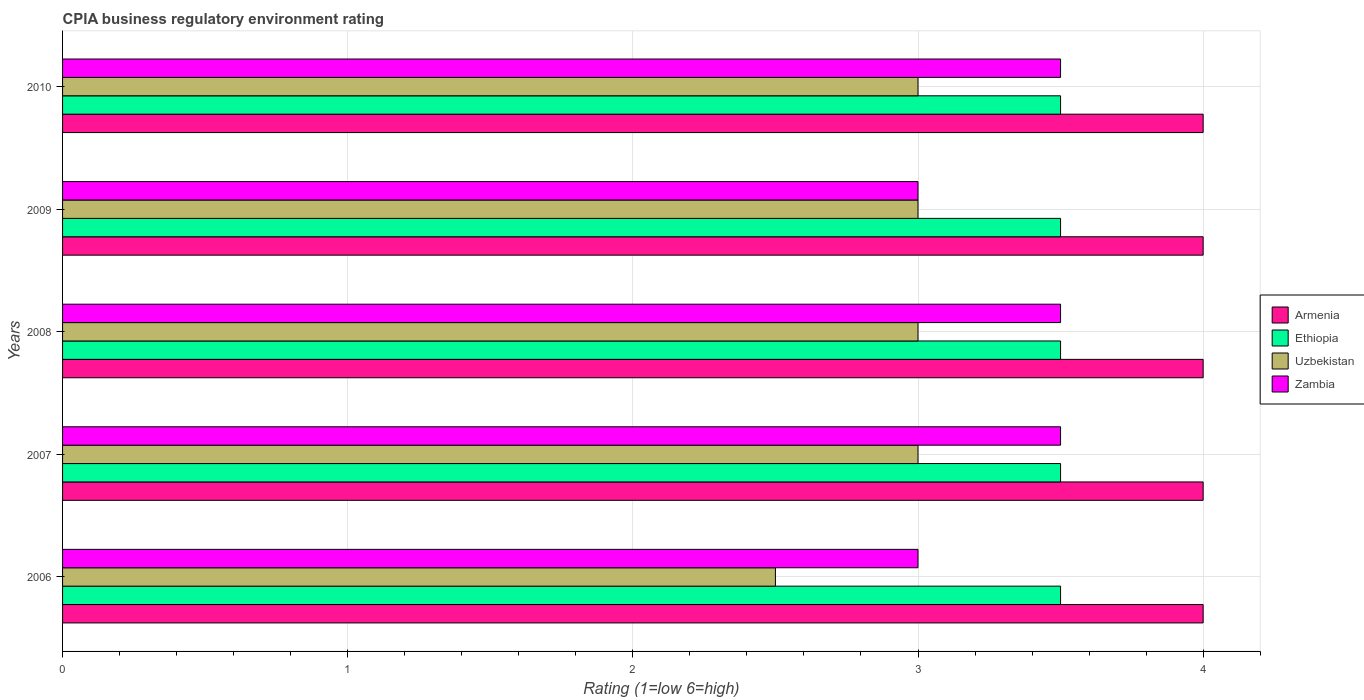How many groups of bars are there?
Offer a terse response. 5. Are the number of bars per tick equal to the number of legend labels?
Offer a very short reply. Yes. Are the number of bars on each tick of the Y-axis equal?
Your answer should be compact. Yes. How many bars are there on the 2nd tick from the top?
Offer a terse response. 4. How many bars are there on the 5th tick from the bottom?
Your answer should be very brief. 4. What is the label of the 3rd group of bars from the top?
Your answer should be compact. 2008. In how many cases, is the number of bars for a given year not equal to the number of legend labels?
Provide a succinct answer. 0. What is the CPIA rating in Zambia in 2007?
Your answer should be very brief. 3.5. What is the total CPIA rating in Armenia in the graph?
Your answer should be compact. 20. What is the difference between the CPIA rating in Armenia in 2007 and that in 2009?
Your response must be concise. 0. What is the average CPIA rating in Ethiopia per year?
Your answer should be very brief. 3.5. In the year 2010, what is the difference between the CPIA rating in Zambia and CPIA rating in Ethiopia?
Your answer should be compact. 0. Is the difference between the CPIA rating in Zambia in 2008 and 2009 greater than the difference between the CPIA rating in Ethiopia in 2008 and 2009?
Give a very brief answer. Yes. In how many years, is the CPIA rating in Armenia greater than the average CPIA rating in Armenia taken over all years?
Make the answer very short. 0. Is the sum of the CPIA rating in Armenia in 2008 and 2009 greater than the maximum CPIA rating in Uzbekistan across all years?
Your response must be concise. Yes. What does the 3rd bar from the top in 2006 represents?
Your response must be concise. Ethiopia. What does the 2nd bar from the bottom in 2010 represents?
Make the answer very short. Ethiopia. Is it the case that in every year, the sum of the CPIA rating in Zambia and CPIA rating in Armenia is greater than the CPIA rating in Ethiopia?
Provide a short and direct response. Yes. How many bars are there?
Keep it short and to the point. 20. What is the difference between two consecutive major ticks on the X-axis?
Give a very brief answer. 1. Are the values on the major ticks of X-axis written in scientific E-notation?
Your response must be concise. No. Does the graph contain any zero values?
Provide a short and direct response. No. Does the graph contain grids?
Offer a very short reply. Yes. Where does the legend appear in the graph?
Offer a terse response. Center right. How many legend labels are there?
Provide a short and direct response. 4. How are the legend labels stacked?
Give a very brief answer. Vertical. What is the title of the graph?
Ensure brevity in your answer.  CPIA business regulatory environment rating. What is the Rating (1=low 6=high) of Armenia in 2006?
Provide a short and direct response. 4. What is the Rating (1=low 6=high) in Armenia in 2007?
Offer a terse response. 4. What is the Rating (1=low 6=high) in Armenia in 2008?
Ensure brevity in your answer.  4. What is the Rating (1=low 6=high) in Ethiopia in 2008?
Ensure brevity in your answer.  3.5. What is the Rating (1=low 6=high) of Ethiopia in 2009?
Your response must be concise. 3.5. What is the Rating (1=low 6=high) of Zambia in 2010?
Your answer should be very brief. 3.5. Across all years, what is the maximum Rating (1=low 6=high) in Armenia?
Give a very brief answer. 4. Across all years, what is the maximum Rating (1=low 6=high) in Uzbekistan?
Make the answer very short. 3. Across all years, what is the maximum Rating (1=low 6=high) in Zambia?
Keep it short and to the point. 3.5. Across all years, what is the minimum Rating (1=low 6=high) of Armenia?
Provide a succinct answer. 4. Across all years, what is the minimum Rating (1=low 6=high) in Uzbekistan?
Offer a terse response. 2.5. Across all years, what is the minimum Rating (1=low 6=high) of Zambia?
Offer a terse response. 3. What is the total Rating (1=low 6=high) of Ethiopia in the graph?
Keep it short and to the point. 17.5. What is the total Rating (1=low 6=high) of Uzbekistan in the graph?
Offer a terse response. 14.5. What is the total Rating (1=low 6=high) in Zambia in the graph?
Provide a short and direct response. 16.5. What is the difference between the Rating (1=low 6=high) of Armenia in 2006 and that in 2008?
Provide a short and direct response. 0. What is the difference between the Rating (1=low 6=high) in Ethiopia in 2006 and that in 2008?
Keep it short and to the point. 0. What is the difference between the Rating (1=low 6=high) in Uzbekistan in 2006 and that in 2008?
Your answer should be very brief. -0.5. What is the difference between the Rating (1=low 6=high) in Zambia in 2006 and that in 2008?
Give a very brief answer. -0.5. What is the difference between the Rating (1=low 6=high) of Ethiopia in 2006 and that in 2009?
Offer a very short reply. 0. What is the difference between the Rating (1=low 6=high) in Uzbekistan in 2006 and that in 2009?
Ensure brevity in your answer.  -0.5. What is the difference between the Rating (1=low 6=high) of Zambia in 2006 and that in 2009?
Your answer should be very brief. 0. What is the difference between the Rating (1=low 6=high) in Armenia in 2006 and that in 2010?
Your answer should be very brief. 0. What is the difference between the Rating (1=low 6=high) of Uzbekistan in 2006 and that in 2010?
Provide a succinct answer. -0.5. What is the difference between the Rating (1=low 6=high) in Zambia in 2006 and that in 2010?
Make the answer very short. -0.5. What is the difference between the Rating (1=low 6=high) of Armenia in 2007 and that in 2008?
Make the answer very short. 0. What is the difference between the Rating (1=low 6=high) of Armenia in 2007 and that in 2009?
Provide a short and direct response. 0. What is the difference between the Rating (1=low 6=high) of Zambia in 2007 and that in 2009?
Your answer should be very brief. 0.5. What is the difference between the Rating (1=low 6=high) of Armenia in 2007 and that in 2010?
Make the answer very short. 0. What is the difference between the Rating (1=low 6=high) of Uzbekistan in 2008 and that in 2009?
Your answer should be very brief. 0. What is the difference between the Rating (1=low 6=high) in Zambia in 2008 and that in 2009?
Provide a succinct answer. 0.5. What is the difference between the Rating (1=low 6=high) in Armenia in 2008 and that in 2010?
Keep it short and to the point. 0. What is the difference between the Rating (1=low 6=high) of Ethiopia in 2009 and that in 2010?
Your answer should be compact. 0. What is the difference between the Rating (1=low 6=high) of Armenia in 2006 and the Rating (1=low 6=high) of Ethiopia in 2007?
Keep it short and to the point. 0.5. What is the difference between the Rating (1=low 6=high) of Armenia in 2006 and the Rating (1=low 6=high) of Zambia in 2007?
Your answer should be compact. 0.5. What is the difference between the Rating (1=low 6=high) of Ethiopia in 2006 and the Rating (1=low 6=high) of Uzbekistan in 2007?
Keep it short and to the point. 0.5. What is the difference between the Rating (1=low 6=high) in Armenia in 2006 and the Rating (1=low 6=high) in Ethiopia in 2008?
Your answer should be very brief. 0.5. What is the difference between the Rating (1=low 6=high) of Armenia in 2006 and the Rating (1=low 6=high) of Zambia in 2008?
Offer a very short reply. 0.5. What is the difference between the Rating (1=low 6=high) of Ethiopia in 2006 and the Rating (1=low 6=high) of Uzbekistan in 2008?
Provide a short and direct response. 0.5. What is the difference between the Rating (1=low 6=high) in Ethiopia in 2006 and the Rating (1=low 6=high) in Zambia in 2008?
Ensure brevity in your answer.  0. What is the difference between the Rating (1=low 6=high) in Armenia in 2006 and the Rating (1=low 6=high) in Uzbekistan in 2009?
Offer a very short reply. 1. What is the difference between the Rating (1=low 6=high) of Ethiopia in 2006 and the Rating (1=low 6=high) of Uzbekistan in 2009?
Make the answer very short. 0.5. What is the difference between the Rating (1=low 6=high) in Ethiopia in 2006 and the Rating (1=low 6=high) in Zambia in 2009?
Keep it short and to the point. 0.5. What is the difference between the Rating (1=low 6=high) in Uzbekistan in 2006 and the Rating (1=low 6=high) in Zambia in 2009?
Make the answer very short. -0.5. What is the difference between the Rating (1=low 6=high) in Armenia in 2006 and the Rating (1=low 6=high) in Uzbekistan in 2010?
Ensure brevity in your answer.  1. What is the difference between the Rating (1=low 6=high) in Armenia in 2006 and the Rating (1=low 6=high) in Zambia in 2010?
Your answer should be compact. 0.5. What is the difference between the Rating (1=low 6=high) in Armenia in 2007 and the Rating (1=low 6=high) in Zambia in 2008?
Provide a succinct answer. 0.5. What is the difference between the Rating (1=low 6=high) of Uzbekistan in 2007 and the Rating (1=low 6=high) of Zambia in 2008?
Offer a very short reply. -0.5. What is the difference between the Rating (1=low 6=high) in Armenia in 2007 and the Rating (1=low 6=high) in Ethiopia in 2009?
Your response must be concise. 0.5. What is the difference between the Rating (1=low 6=high) of Armenia in 2007 and the Rating (1=low 6=high) of Uzbekistan in 2009?
Provide a succinct answer. 1. What is the difference between the Rating (1=low 6=high) in Ethiopia in 2007 and the Rating (1=low 6=high) in Zambia in 2009?
Your answer should be compact. 0.5. What is the difference between the Rating (1=low 6=high) of Uzbekistan in 2007 and the Rating (1=low 6=high) of Zambia in 2009?
Provide a short and direct response. 0. What is the difference between the Rating (1=low 6=high) of Armenia in 2007 and the Rating (1=low 6=high) of Uzbekistan in 2010?
Provide a short and direct response. 1. What is the difference between the Rating (1=low 6=high) in Armenia in 2007 and the Rating (1=low 6=high) in Zambia in 2010?
Your answer should be very brief. 0.5. What is the difference between the Rating (1=low 6=high) in Armenia in 2008 and the Rating (1=low 6=high) in Zambia in 2009?
Give a very brief answer. 1. What is the difference between the Rating (1=low 6=high) in Armenia in 2008 and the Rating (1=low 6=high) in Ethiopia in 2010?
Offer a terse response. 0.5. What is the difference between the Rating (1=low 6=high) in Ethiopia in 2008 and the Rating (1=low 6=high) in Uzbekistan in 2010?
Keep it short and to the point. 0.5. What is the difference between the Rating (1=low 6=high) in Uzbekistan in 2008 and the Rating (1=low 6=high) in Zambia in 2010?
Provide a short and direct response. -0.5. What is the difference between the Rating (1=low 6=high) in Armenia in 2009 and the Rating (1=low 6=high) in Ethiopia in 2010?
Offer a terse response. 0.5. What is the difference between the Rating (1=low 6=high) in Ethiopia in 2009 and the Rating (1=low 6=high) in Zambia in 2010?
Make the answer very short. 0. What is the difference between the Rating (1=low 6=high) in Uzbekistan in 2009 and the Rating (1=low 6=high) in Zambia in 2010?
Ensure brevity in your answer.  -0.5. What is the average Rating (1=low 6=high) of Ethiopia per year?
Offer a terse response. 3.5. What is the average Rating (1=low 6=high) in Uzbekistan per year?
Make the answer very short. 2.9. In the year 2007, what is the difference between the Rating (1=low 6=high) of Armenia and Rating (1=low 6=high) of Ethiopia?
Your response must be concise. 0.5. In the year 2007, what is the difference between the Rating (1=low 6=high) of Ethiopia and Rating (1=low 6=high) of Uzbekistan?
Offer a terse response. 0.5. In the year 2008, what is the difference between the Rating (1=low 6=high) of Armenia and Rating (1=low 6=high) of Ethiopia?
Your answer should be compact. 0.5. In the year 2008, what is the difference between the Rating (1=low 6=high) of Armenia and Rating (1=low 6=high) of Uzbekistan?
Give a very brief answer. 1. In the year 2008, what is the difference between the Rating (1=low 6=high) of Armenia and Rating (1=low 6=high) of Zambia?
Keep it short and to the point. 0.5. In the year 2009, what is the difference between the Rating (1=low 6=high) of Armenia and Rating (1=low 6=high) of Ethiopia?
Provide a succinct answer. 0.5. In the year 2009, what is the difference between the Rating (1=low 6=high) of Ethiopia and Rating (1=low 6=high) of Uzbekistan?
Provide a succinct answer. 0.5. In the year 2010, what is the difference between the Rating (1=low 6=high) in Armenia and Rating (1=low 6=high) in Zambia?
Give a very brief answer. 0.5. What is the ratio of the Rating (1=low 6=high) in Uzbekistan in 2006 to that in 2007?
Ensure brevity in your answer.  0.83. What is the ratio of the Rating (1=low 6=high) of Zambia in 2006 to that in 2007?
Your answer should be very brief. 0.86. What is the ratio of the Rating (1=low 6=high) of Armenia in 2006 to that in 2008?
Keep it short and to the point. 1. What is the ratio of the Rating (1=low 6=high) of Zambia in 2006 to that in 2008?
Offer a terse response. 0.86. What is the ratio of the Rating (1=low 6=high) of Uzbekistan in 2006 to that in 2009?
Ensure brevity in your answer.  0.83. What is the ratio of the Rating (1=low 6=high) in Zambia in 2006 to that in 2009?
Provide a succinct answer. 1. What is the ratio of the Rating (1=low 6=high) of Armenia in 2006 to that in 2010?
Offer a terse response. 1. What is the ratio of the Rating (1=low 6=high) in Ethiopia in 2006 to that in 2010?
Offer a very short reply. 1. What is the ratio of the Rating (1=low 6=high) in Armenia in 2007 to that in 2008?
Your response must be concise. 1. What is the ratio of the Rating (1=low 6=high) in Ethiopia in 2007 to that in 2008?
Keep it short and to the point. 1. What is the ratio of the Rating (1=low 6=high) of Uzbekistan in 2007 to that in 2008?
Make the answer very short. 1. What is the ratio of the Rating (1=low 6=high) of Zambia in 2007 to that in 2008?
Provide a succinct answer. 1. What is the ratio of the Rating (1=low 6=high) of Armenia in 2007 to that in 2009?
Ensure brevity in your answer.  1. What is the ratio of the Rating (1=low 6=high) in Uzbekistan in 2007 to that in 2009?
Ensure brevity in your answer.  1. What is the ratio of the Rating (1=low 6=high) of Armenia in 2007 to that in 2010?
Make the answer very short. 1. What is the ratio of the Rating (1=low 6=high) of Zambia in 2007 to that in 2010?
Your answer should be very brief. 1. What is the ratio of the Rating (1=low 6=high) of Ethiopia in 2008 to that in 2009?
Your answer should be compact. 1. What is the ratio of the Rating (1=low 6=high) in Zambia in 2008 to that in 2009?
Make the answer very short. 1.17. What is the ratio of the Rating (1=low 6=high) in Ethiopia in 2009 to that in 2010?
Your answer should be very brief. 1. What is the ratio of the Rating (1=low 6=high) in Uzbekistan in 2009 to that in 2010?
Keep it short and to the point. 1. What is the difference between the highest and the second highest Rating (1=low 6=high) of Armenia?
Offer a very short reply. 0. What is the difference between the highest and the second highest Rating (1=low 6=high) in Ethiopia?
Your answer should be compact. 0. What is the difference between the highest and the second highest Rating (1=low 6=high) in Uzbekistan?
Give a very brief answer. 0. What is the difference between the highest and the lowest Rating (1=low 6=high) in Zambia?
Your answer should be very brief. 0.5. 